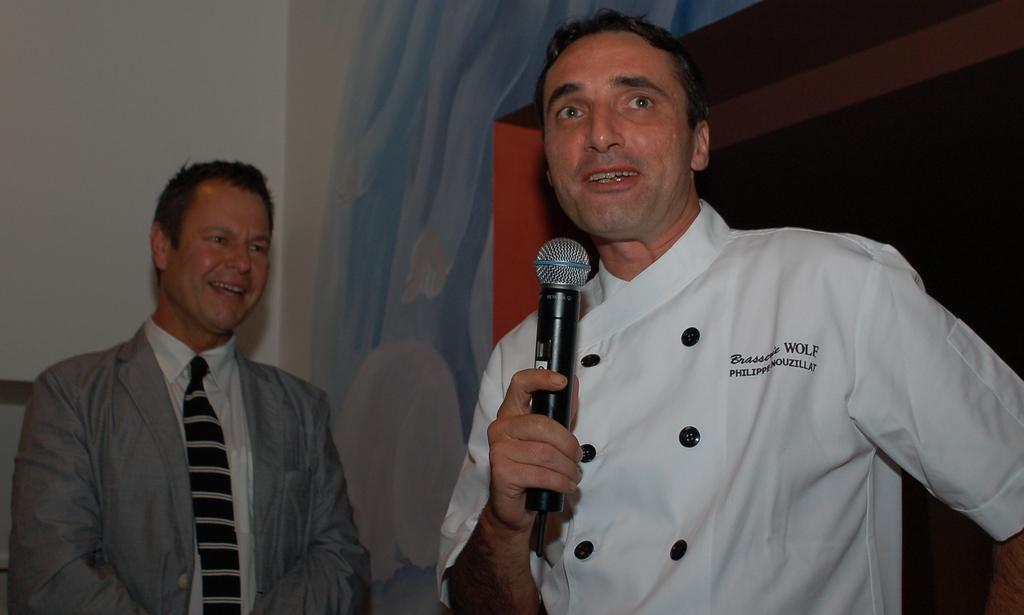How many people are in the image? There are two people in the image. What is the person wearing on the left side of the image wearing? The person on the left side of the image is wearing a white shirt. What is the person in the white shirt holding? The person in the white shirt is holding a microphone. What is the person on the right side of the image wearing? The person on the right side of the image is wearing an ash-colored suit. What type of car can be seen in the background of the image? There is no car visible in the image. How does the acoustics of the room affect the sound quality of the show? The image does not provide any information about the acoustics of the room or the sound quality of a show. 